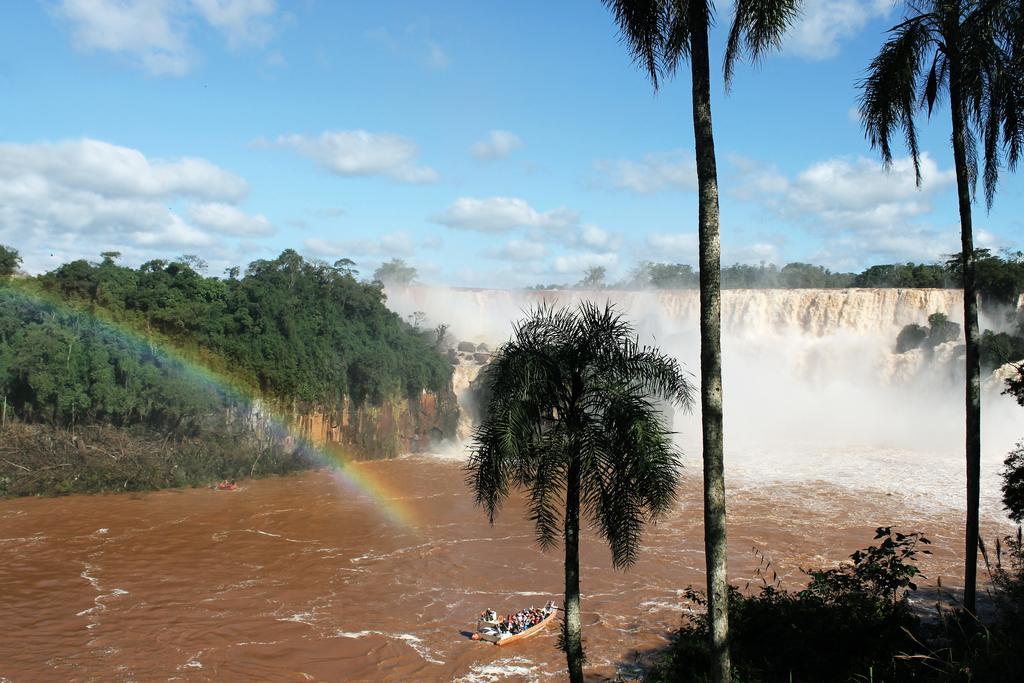Describe this image in one or two sentences. This is the picture of a waterfall. In this image there are group of people in the boat, there is a boat on the water. On the left side of the image there is a rainbow and there are trees. At the back there is a waterfall. In the foreground there are trees. At the top there is sky and there are clouds. At the bottom there is water. 